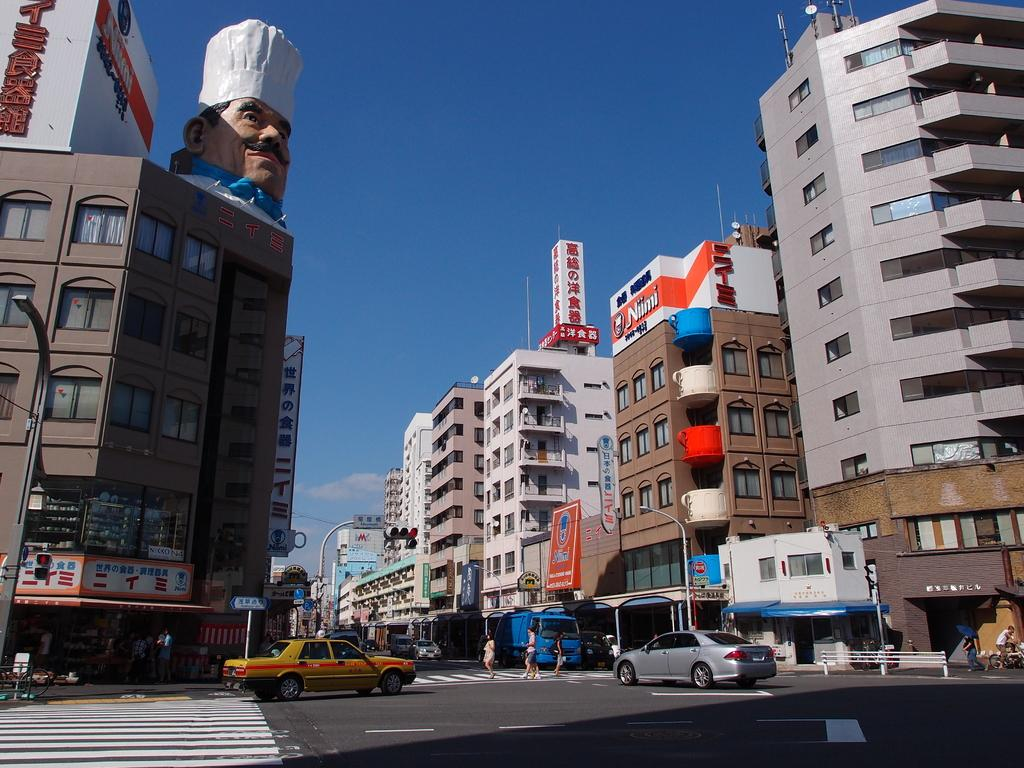What can be seen on the roads in the image? There are white lines on the roads in the image. What types of objects are present on the roads? There are vehicles in the image. What structures can be seen in the image? There are buildings in the image. What are the boards used for in the image? There are boards in the image, and they have writing on them. Who is present in the image? There are people in the image. What is visible in the sky in the image? There are clouds in the image, and the sky is visible. What type of machine can be seen playing with the balls in the image? There is no machine or balls present in the image. What is the argument about in the image? There is no argument depicted in the image. 